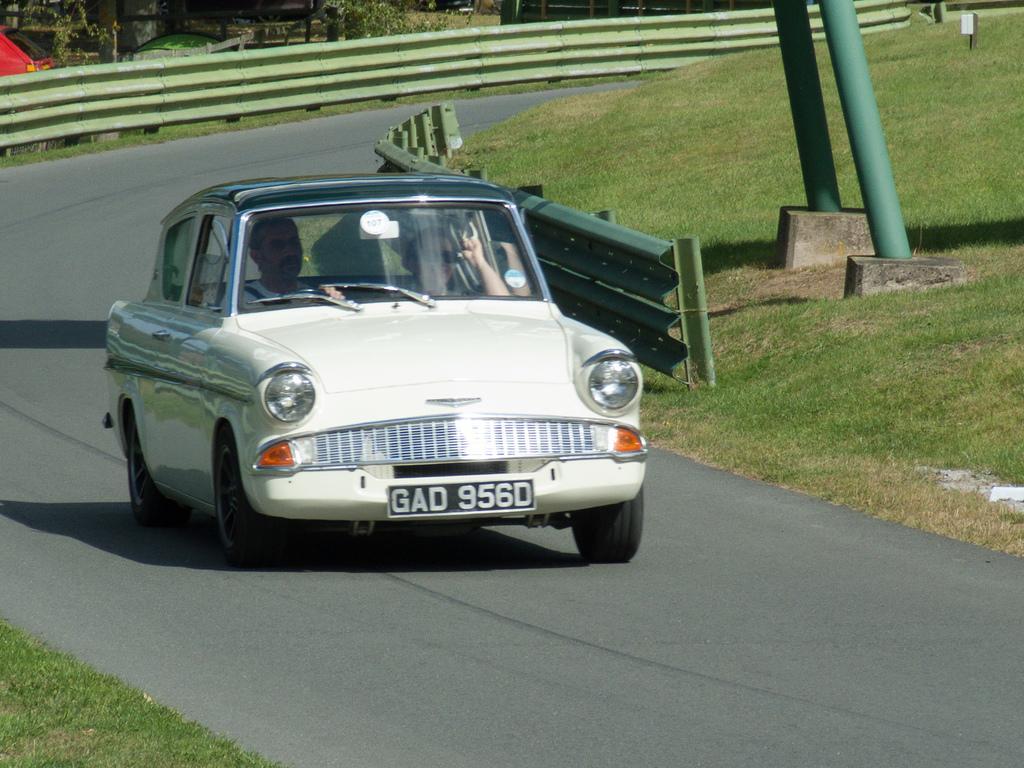Please provide a concise description of this image. In this picture there is a car moving on the road with the persons sitting inside it in the center. On the right side there is grass on the ground. There are poles which are green in colour and there is a fence. In the background there are trees and red colour object. 